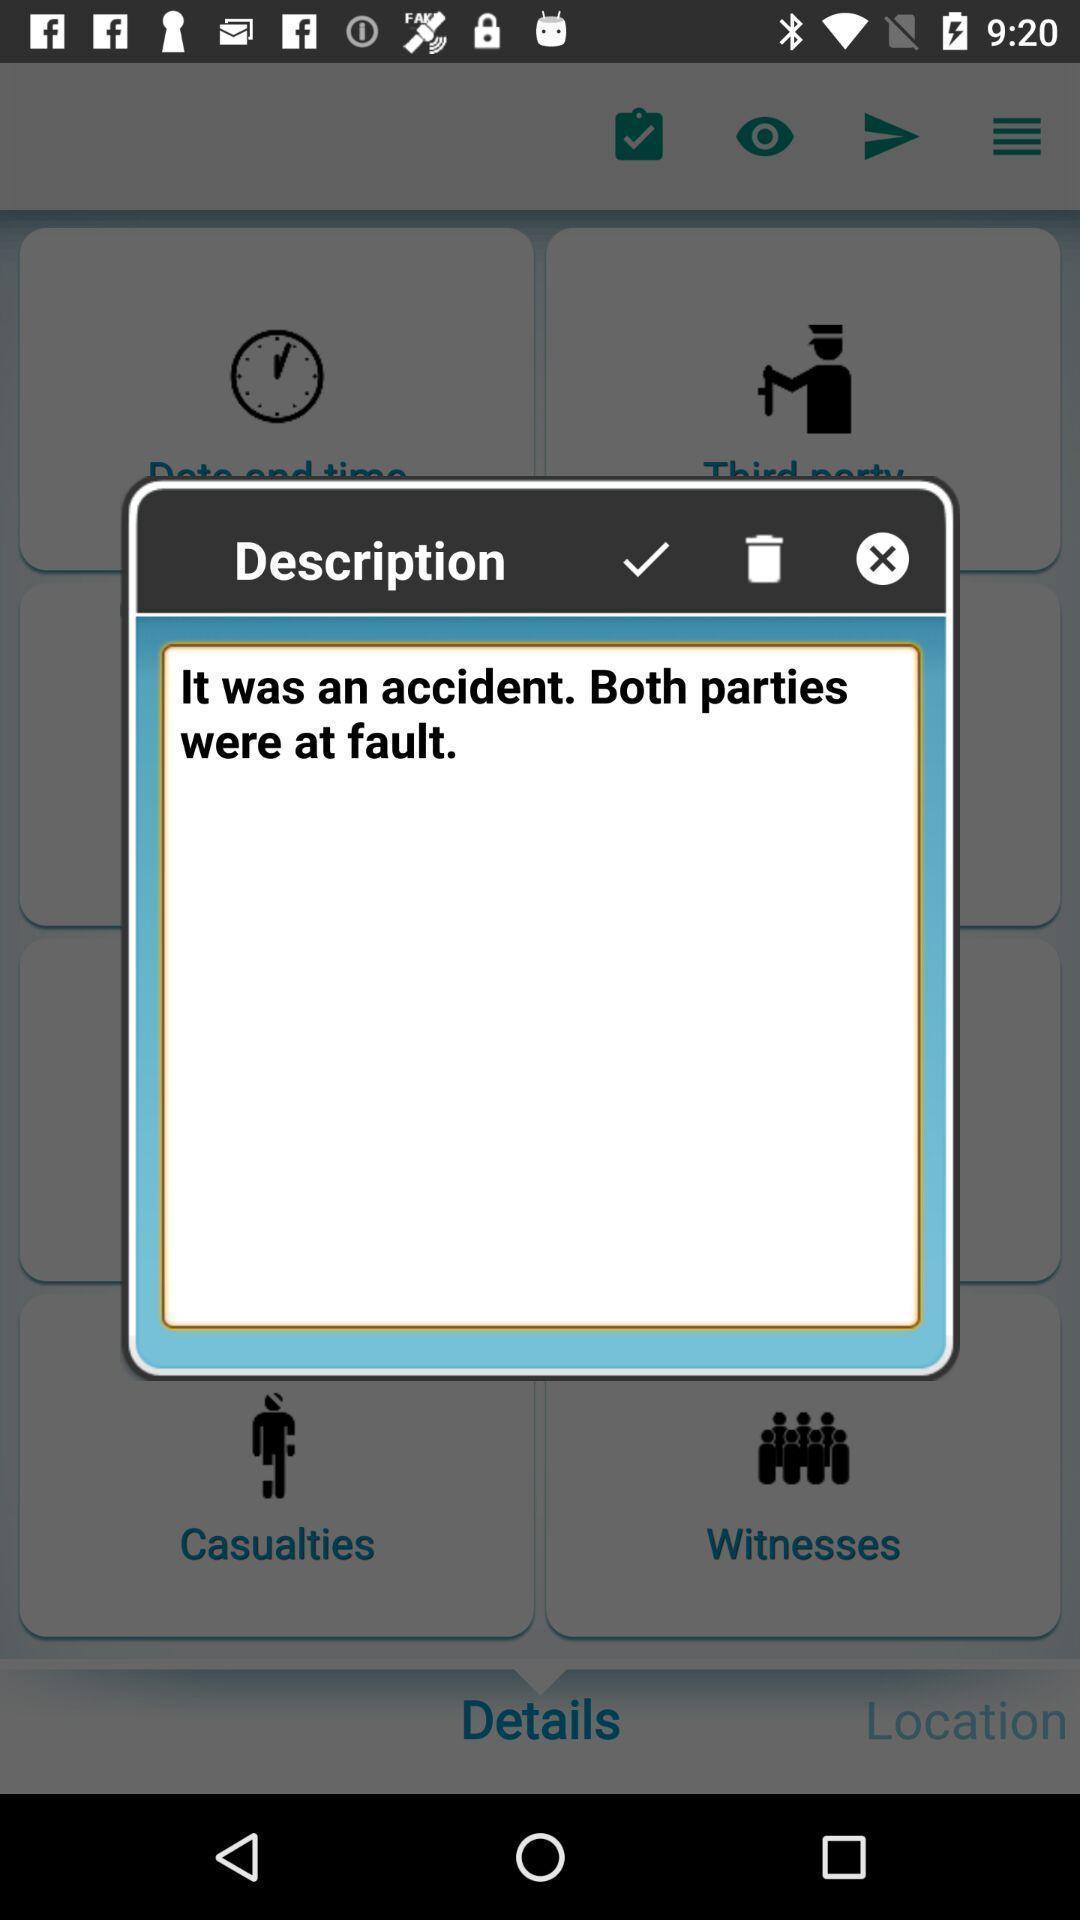What is the overall content of this screenshot? Pop-up with description. 